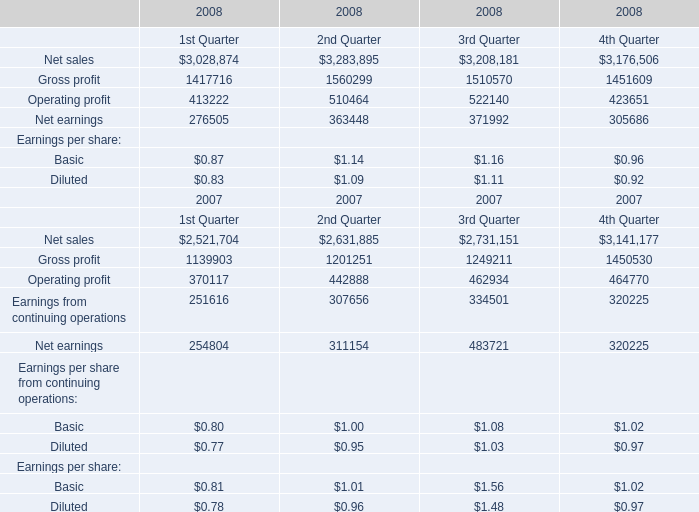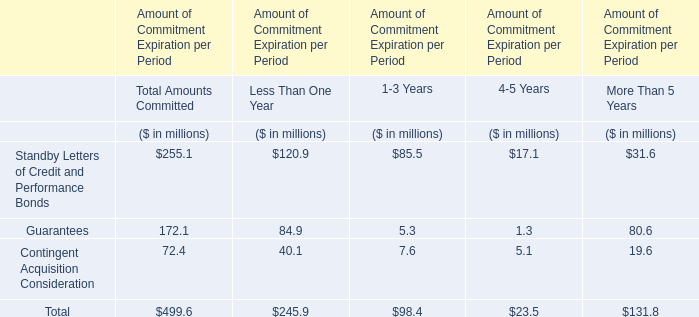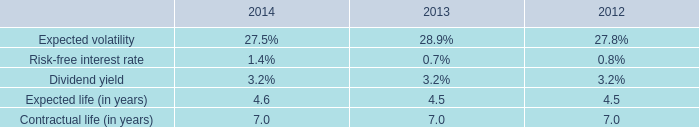In what year is Net earnings greater than 480000? 
Answer: 2007. 